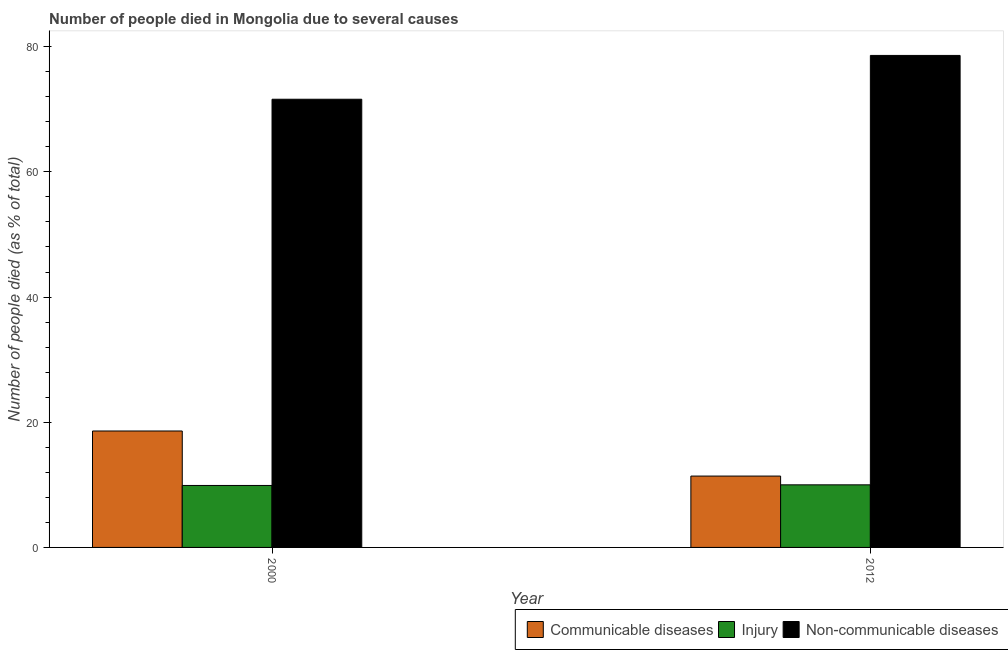How many groups of bars are there?
Offer a very short reply. 2. How many bars are there on the 2nd tick from the right?
Your response must be concise. 3. In how many cases, is the number of bars for a given year not equal to the number of legend labels?
Provide a succinct answer. 0. What is the number of people who died of communicable diseases in 2012?
Your answer should be compact. 11.4. Across all years, what is the maximum number of people who died of injury?
Your answer should be very brief. 10. In which year was the number of people who died of communicable diseases maximum?
Ensure brevity in your answer.  2000. What is the total number of people who died of injury in the graph?
Your answer should be compact. 19.9. What is the difference between the number of people who died of injury in 2000 and the number of people who dies of non-communicable diseases in 2012?
Your answer should be very brief. -0.1. What is the average number of people who dies of non-communicable diseases per year?
Make the answer very short. 75.1. In how many years, is the number of people who died of communicable diseases greater than 40 %?
Ensure brevity in your answer.  0. What is the ratio of the number of people who died of communicable diseases in 2000 to that in 2012?
Offer a terse response. 1.63. In how many years, is the number of people who died of injury greater than the average number of people who died of injury taken over all years?
Ensure brevity in your answer.  1. What does the 3rd bar from the left in 2012 represents?
Give a very brief answer. Non-communicable diseases. What does the 1st bar from the right in 2000 represents?
Your answer should be compact. Non-communicable diseases. Is it the case that in every year, the sum of the number of people who died of communicable diseases and number of people who died of injury is greater than the number of people who dies of non-communicable diseases?
Make the answer very short. No. How many bars are there?
Offer a very short reply. 6. How many years are there in the graph?
Provide a short and direct response. 2. What is the difference between two consecutive major ticks on the Y-axis?
Provide a succinct answer. 20. Are the values on the major ticks of Y-axis written in scientific E-notation?
Your response must be concise. No. How many legend labels are there?
Keep it short and to the point. 3. How are the legend labels stacked?
Keep it short and to the point. Horizontal. What is the title of the graph?
Keep it short and to the point. Number of people died in Mongolia due to several causes. What is the label or title of the X-axis?
Ensure brevity in your answer.  Year. What is the label or title of the Y-axis?
Keep it short and to the point. Number of people died (as % of total). What is the Number of people died (as % of total) in Communicable diseases in 2000?
Keep it short and to the point. 18.6. What is the Number of people died (as % of total) of Injury in 2000?
Your answer should be very brief. 9.9. What is the Number of people died (as % of total) in Non-communicable diseases in 2000?
Give a very brief answer. 71.6. What is the Number of people died (as % of total) in Communicable diseases in 2012?
Make the answer very short. 11.4. What is the Number of people died (as % of total) of Injury in 2012?
Your answer should be compact. 10. What is the Number of people died (as % of total) of Non-communicable diseases in 2012?
Keep it short and to the point. 78.6. Across all years, what is the maximum Number of people died (as % of total) of Injury?
Ensure brevity in your answer.  10. Across all years, what is the maximum Number of people died (as % of total) of Non-communicable diseases?
Give a very brief answer. 78.6. Across all years, what is the minimum Number of people died (as % of total) in Non-communicable diseases?
Provide a short and direct response. 71.6. What is the total Number of people died (as % of total) of Communicable diseases in the graph?
Your response must be concise. 30. What is the total Number of people died (as % of total) in Non-communicable diseases in the graph?
Ensure brevity in your answer.  150.2. What is the difference between the Number of people died (as % of total) in Communicable diseases in 2000 and that in 2012?
Offer a very short reply. 7.2. What is the difference between the Number of people died (as % of total) of Communicable diseases in 2000 and the Number of people died (as % of total) of Non-communicable diseases in 2012?
Offer a very short reply. -60. What is the difference between the Number of people died (as % of total) of Injury in 2000 and the Number of people died (as % of total) of Non-communicable diseases in 2012?
Your answer should be very brief. -68.7. What is the average Number of people died (as % of total) of Injury per year?
Offer a terse response. 9.95. What is the average Number of people died (as % of total) in Non-communicable diseases per year?
Your response must be concise. 75.1. In the year 2000, what is the difference between the Number of people died (as % of total) in Communicable diseases and Number of people died (as % of total) in Non-communicable diseases?
Offer a very short reply. -53. In the year 2000, what is the difference between the Number of people died (as % of total) in Injury and Number of people died (as % of total) in Non-communicable diseases?
Provide a succinct answer. -61.7. In the year 2012, what is the difference between the Number of people died (as % of total) of Communicable diseases and Number of people died (as % of total) of Non-communicable diseases?
Make the answer very short. -67.2. In the year 2012, what is the difference between the Number of people died (as % of total) in Injury and Number of people died (as % of total) in Non-communicable diseases?
Provide a succinct answer. -68.6. What is the ratio of the Number of people died (as % of total) in Communicable diseases in 2000 to that in 2012?
Provide a succinct answer. 1.63. What is the ratio of the Number of people died (as % of total) of Non-communicable diseases in 2000 to that in 2012?
Offer a very short reply. 0.91. What is the difference between the highest and the lowest Number of people died (as % of total) in Non-communicable diseases?
Provide a succinct answer. 7. 